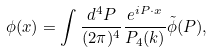Convert formula to latex. <formula><loc_0><loc_0><loc_500><loc_500>\phi ( x ) = \int \frac { d ^ { 4 } P } { ( 2 \pi ) ^ { 4 } } \frac { e ^ { i P \cdot x } } { P _ { 4 } ( k ) } \tilde { \phi } ( P ) ,</formula> 